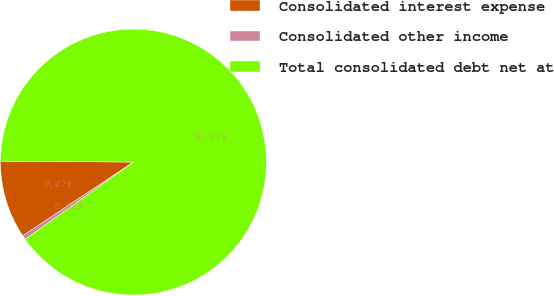Convert chart to OTSL. <chart><loc_0><loc_0><loc_500><loc_500><pie_chart><fcel>Consolidated interest expense<fcel>Consolidated other income<fcel>Total consolidated debt net at<nl><fcel>9.47%<fcel>0.52%<fcel>90.02%<nl></chart> 